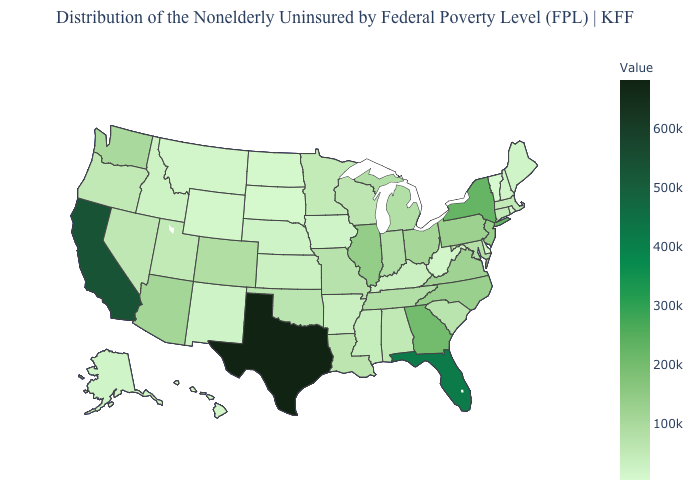Which states hav the highest value in the Northeast?
Give a very brief answer. New York. Among the states that border Montana , which have the highest value?
Write a very short answer. Idaho. Does California have a lower value than Texas?
Give a very brief answer. Yes. Does California have a lower value than South Carolina?
Quick response, please. No. Does Maryland have the lowest value in the South?
Write a very short answer. No. Which states have the highest value in the USA?
Give a very brief answer. Texas. 